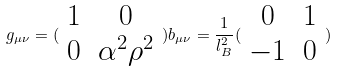Convert formula to latex. <formula><loc_0><loc_0><loc_500><loc_500>g _ { \mu \nu } = ( \begin{array} { c c } 1 & 0 \\ 0 & \alpha ^ { 2 } \rho ^ { 2 } \end{array} ) b _ { \mu \nu } = \frac { 1 } { l _ { B } ^ { 2 } } ( \begin{array} { c c } 0 & 1 \\ - 1 & 0 \end{array} )</formula> 